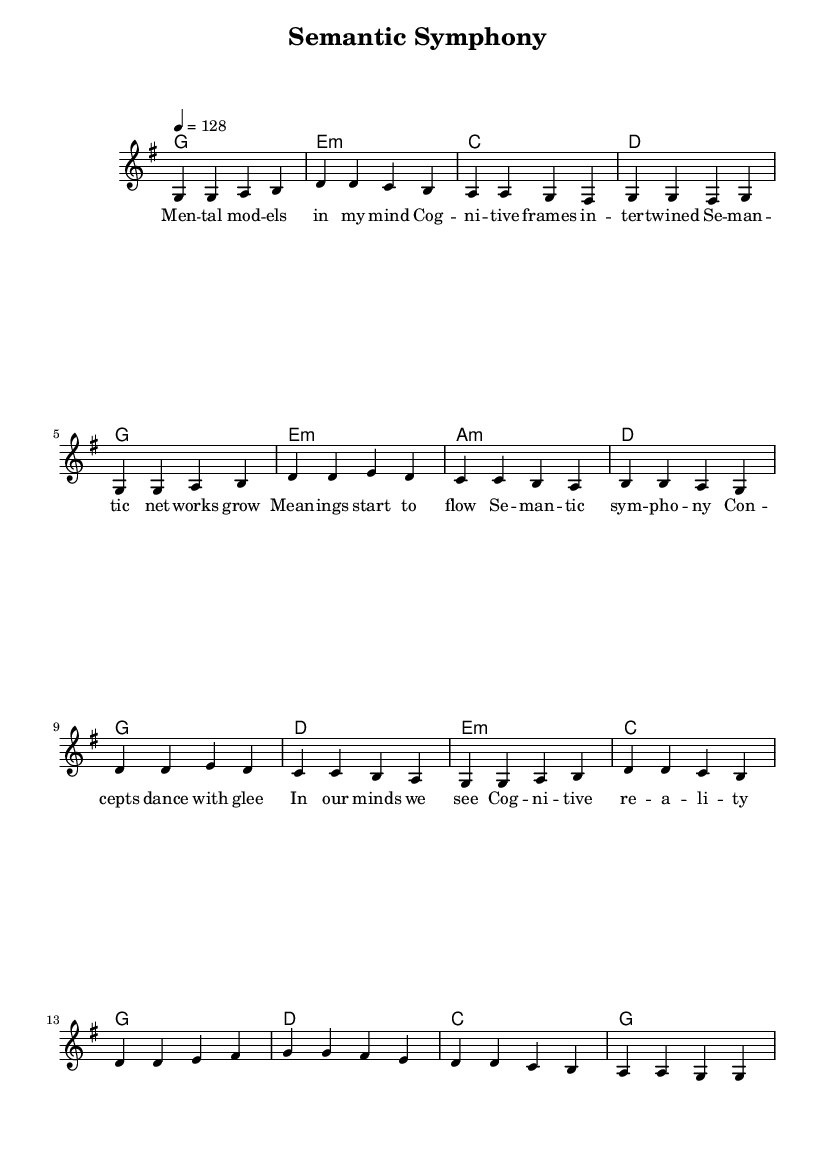What is the key signature of this music? The key signature is G major, which includes one sharp (F#). This can be identified from the presence of one sharp at the beginning of the staff.
Answer: G major What is the time signature of this music? The time signature is 4/4, which is indicated at the beginning of the staff with the numeric fraction reflecting four beats per measure.
Answer: 4/4 What tempo marking is stated for this piece? The tempo marking is 4 = 128, meaning the quarter note gets 128 beats per minute. This is found near the beginning section of the score.
Answer: 128 How many measures are in the verse section? The verse section consists of 8 measures, as can be counted from the melody notation in the score.
Answer: 8 What is the primary theme conveyed in the lyrics? The primary theme involves cognitive semantics, as evident in phrases like "mental models" and "cognitive frames," which highlight mental constructs and relationships.
Answer: Cognitive semantics How many chords are used in the chorus section? There are 5 unique chords in the chorus section: G, D, E minor, C, and G, as identified by the chord indications written above the lyrics during the chorus part of the score.
Answer: 5 What does the phrase "Semantic symphony" refer to in the context of the song? The phrase "Semantic symphony" represents the idea of harmonizing thoughts and meanings, emphasizing the interconnectivity of concepts in cognitive theory, as expressed in the chorus.
Answer: Harmonizing concepts 